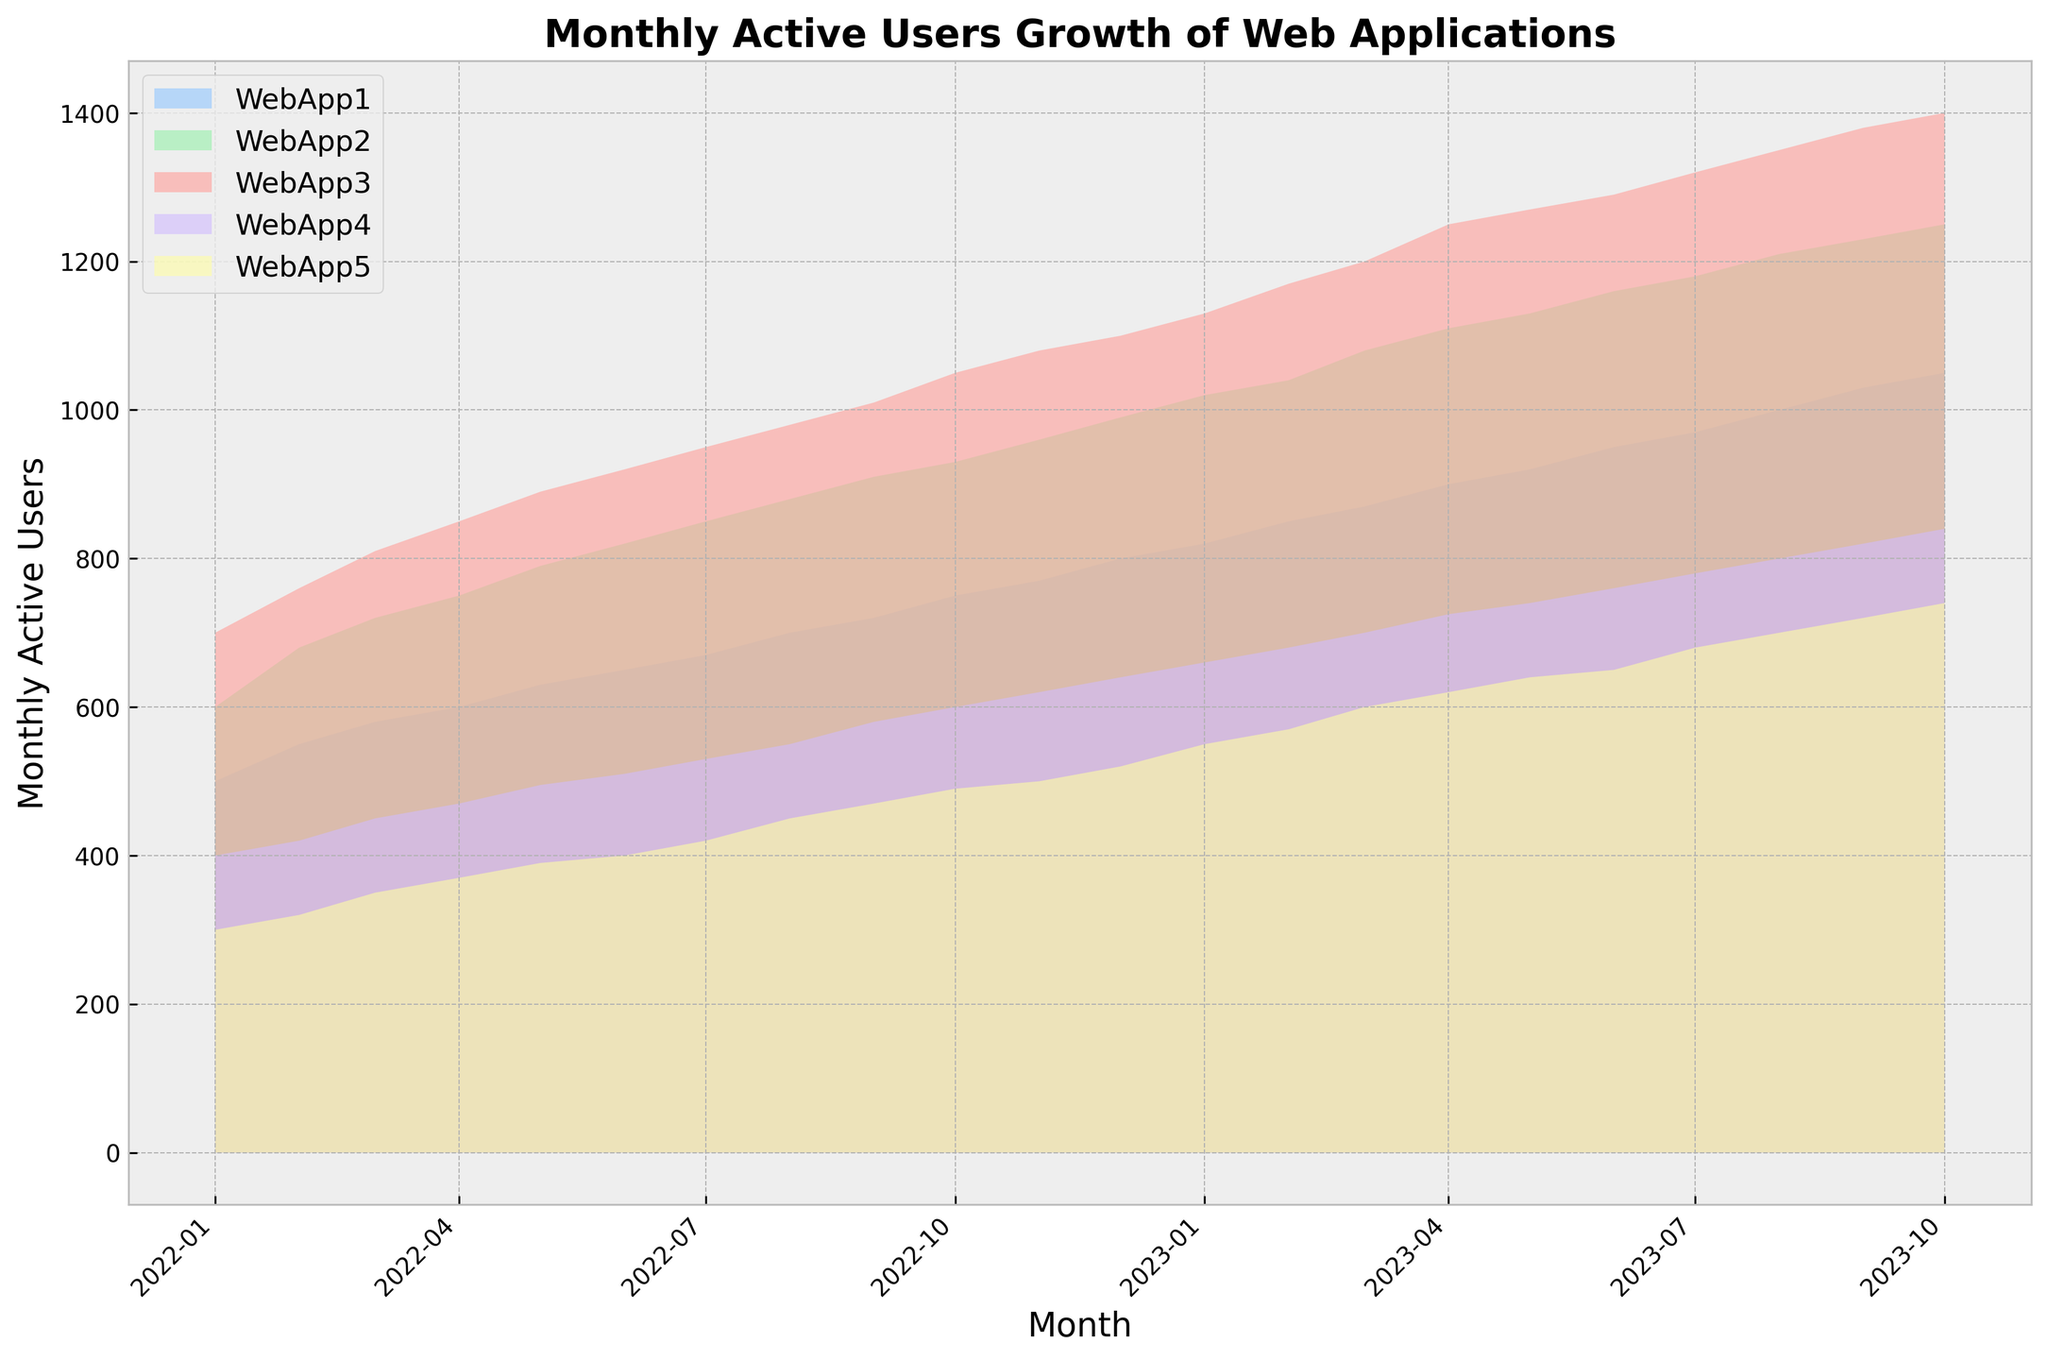What's the overall trend for WebApp1 from January 2022 to October 2023? To determine the trend, observe the area filled for WebApp1 across the timeline. The area consistently increases from left to right, indicating that the number of Monthly Active Users is growing.
Answer: Growing trend Which web application had the least number of Monthly Active Users in January 2022? Compare the filled areas for each web application in January 2022. WebApp5 has the smallest area compared to others.
Answer: WebApp5 How does the growth of Monthly Active Users for WebApp3 between January 2022 and January 2023 compare to the growth of WebApp4 in the same period? Look at the change in height for WebApp3 and WebApp4 from January 2022 to January 2023. WebApp3 grows from 700 to 1100 users (an increase of 400 users), while WebApp4 grows from 400 to 660 users (an increase of 260 users).
Answer: WebApp3 grows more What is the approximate difference in the number of Monthly Active Users between WebApp2 and WebApp5 in October 2023? Compare the heights of the filled areas for WebApp2 and WebApp5 in October 2023. WebApp2 has about 1250 users, and WebApp5 has about 740 users. The difference is approximately 1250 - 740 = 510 users.
Answer: 510 users Which web application experienced the most significant growth rate from January 2022 to October 2023? To find the most significant growth, calculate the difference in Monthly Active Users from start to end for each web application and compare them. WebApp3 grows from 700 to 1400 users, showing the highest numerical growth of 700 users.
Answer: WebApp3 In which month did WebApp2 surpass 1000 Monthly Active Users? Look at the height of the filled area for WebApp2 slightly surpassing the 1000 mark. This occurs in January 2023.
Answer: January 2023 Between May 2023 and August 2023, which web application showed a noticeable acceleration in Monthly Active Users growth? Observe the steepness and the increase in height of the area for each application between May 2023 and August 2023. WebApp1 shows a noticeable acceleration in this period.
Answer: WebApp1 Which period shows the most stable user base for WebApp4? Look for the period where the height of the filled area for WebApp4 remains relatively constant. The period from February 2023 to June 2023 shows the most stability for WebApp4.
Answer: February 2023 to June 2023 What can you infer about the relative sizes of the user bases for WebApp1 and WebApp3 throughout 2022? Throughout 2022, observe that the filled area for WebApp3 is consistently larger than that for WebApp1. This implies WebApp3 has a larger user base compared to WebApp1 throughout the year.
Answer: WebApp3 has a larger user base 